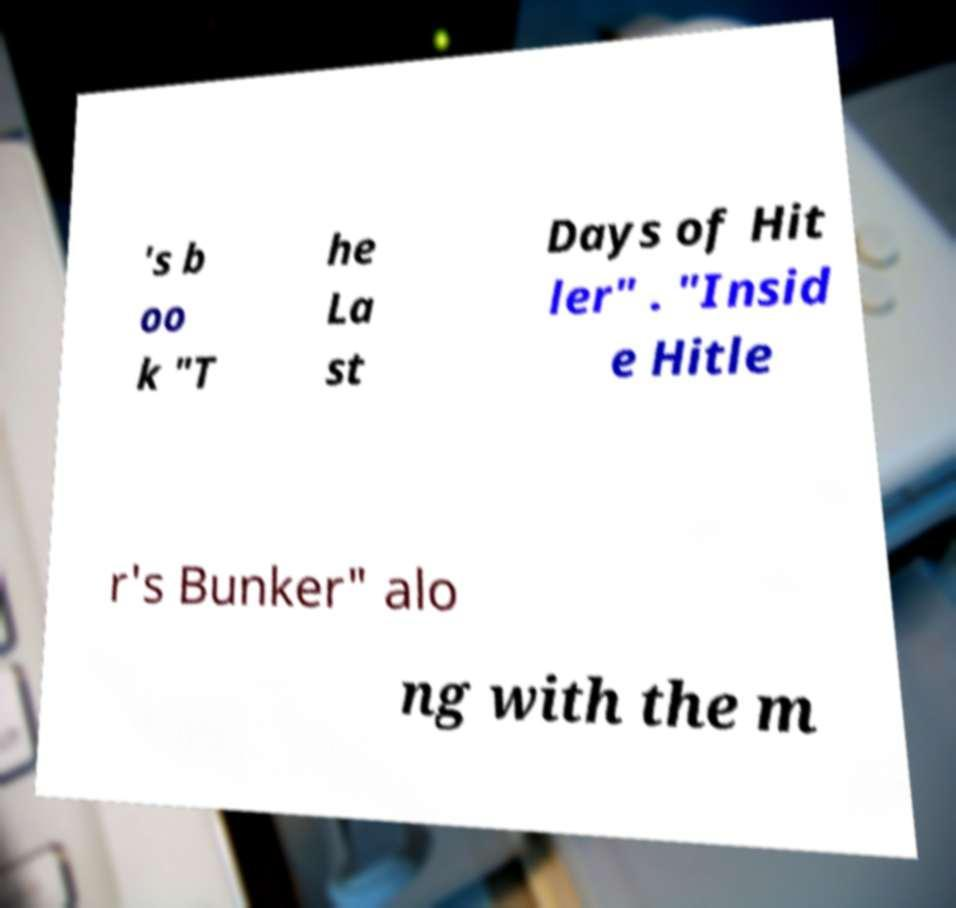What messages or text are displayed in this image? I need them in a readable, typed format. 's b oo k "T he La st Days of Hit ler" . "Insid e Hitle r's Bunker" alo ng with the m 